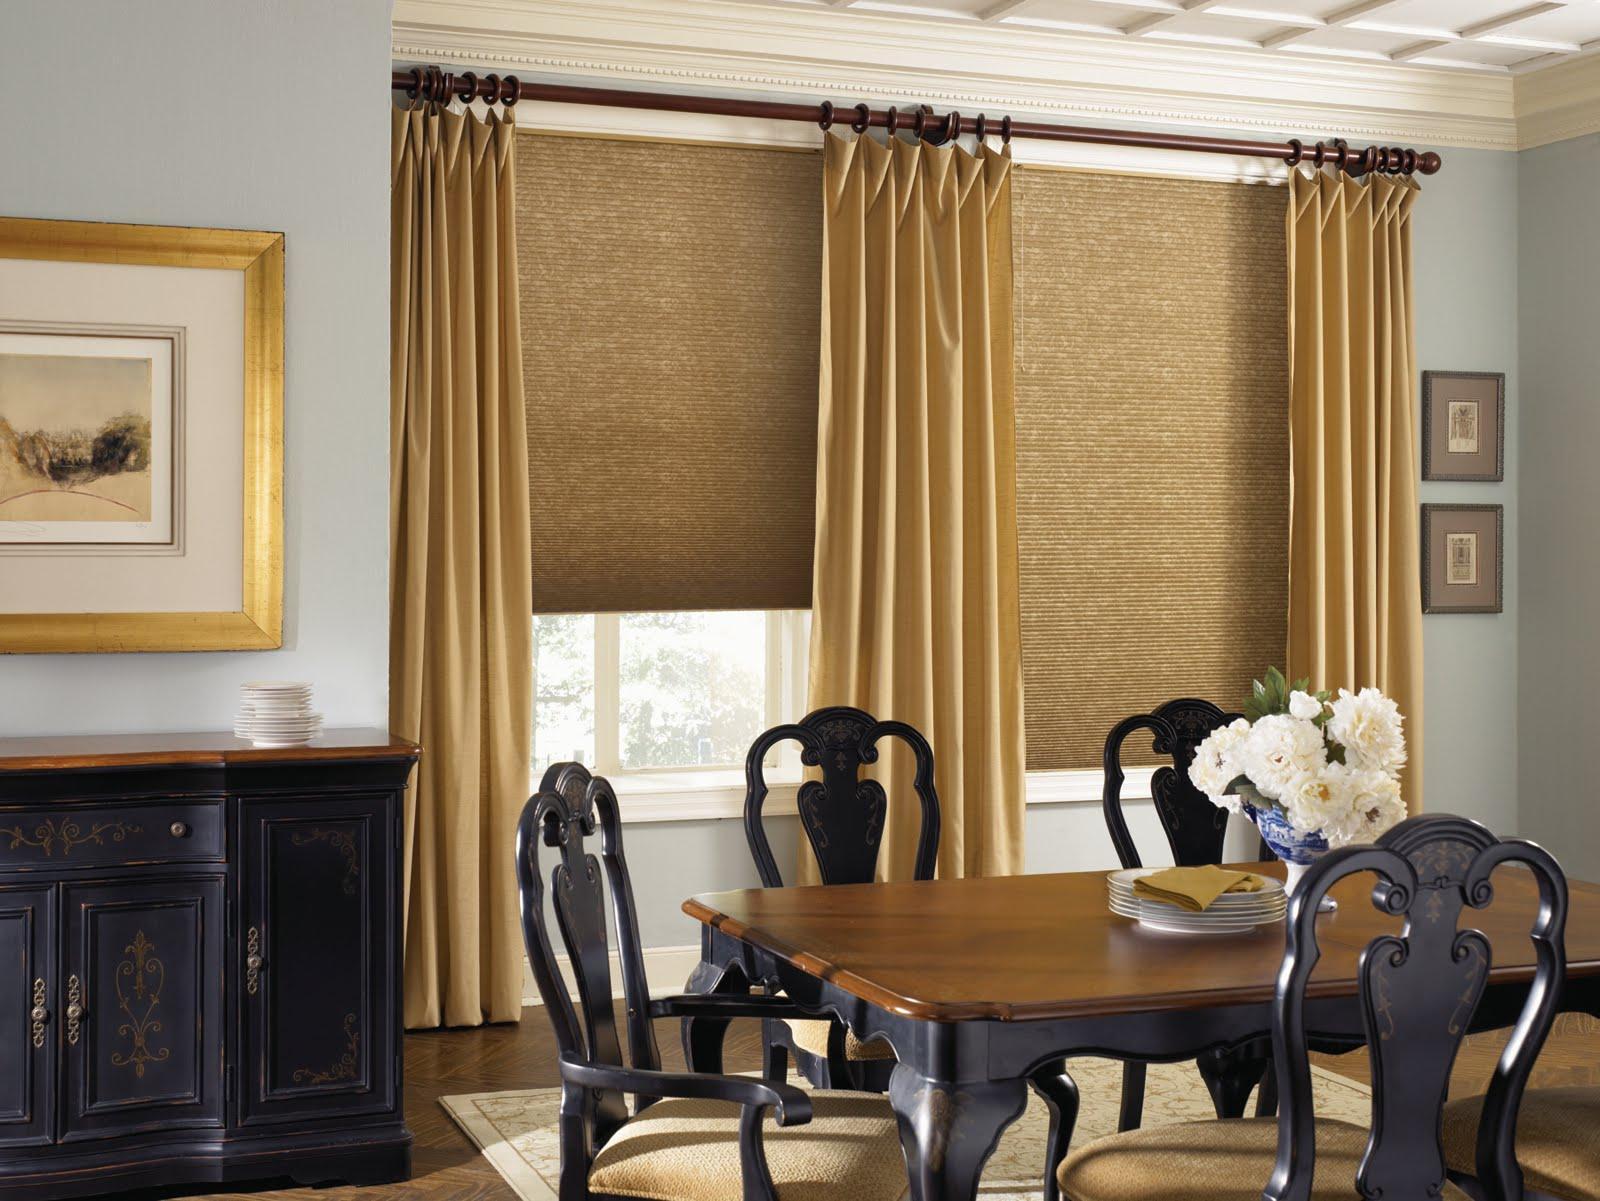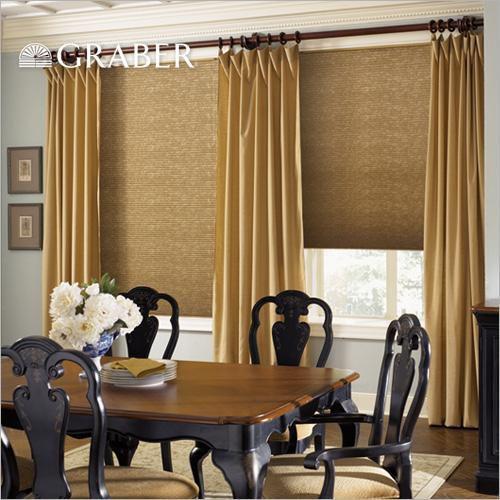The first image is the image on the left, the second image is the image on the right. Given the left and right images, does the statement "An image shows a room with dark-colored walls and at least four brown shades on windows with light-colored frames and no drapes." hold true? Answer yes or no. No. The first image is the image on the left, the second image is the image on the right. Assess this claim about the two images: "Shades are at least partially open in both images.". Correct or not? Answer yes or no. Yes. 